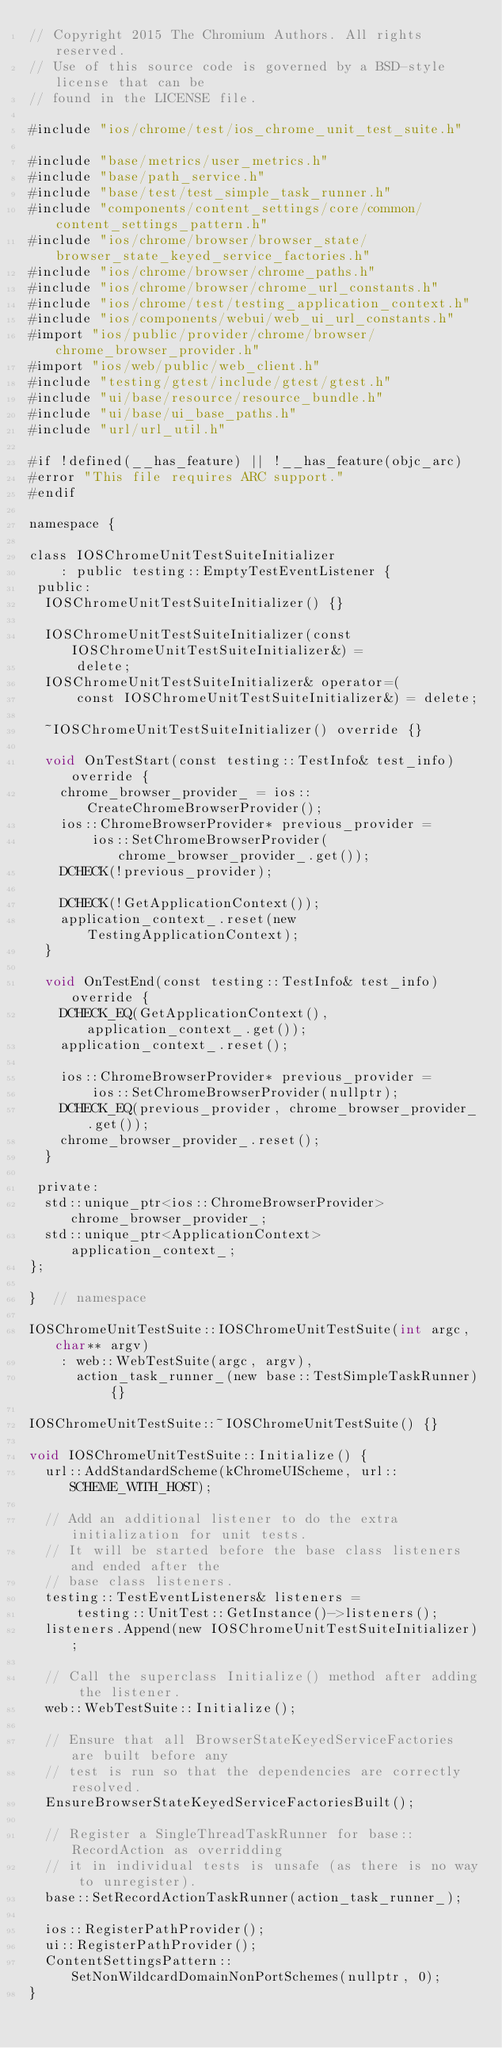<code> <loc_0><loc_0><loc_500><loc_500><_ObjectiveC_>// Copyright 2015 The Chromium Authors. All rights reserved.
// Use of this source code is governed by a BSD-style license that can be
// found in the LICENSE file.

#include "ios/chrome/test/ios_chrome_unit_test_suite.h"

#include "base/metrics/user_metrics.h"
#include "base/path_service.h"
#include "base/test/test_simple_task_runner.h"
#include "components/content_settings/core/common/content_settings_pattern.h"
#include "ios/chrome/browser/browser_state/browser_state_keyed_service_factories.h"
#include "ios/chrome/browser/chrome_paths.h"
#include "ios/chrome/browser/chrome_url_constants.h"
#include "ios/chrome/test/testing_application_context.h"
#include "ios/components/webui/web_ui_url_constants.h"
#import "ios/public/provider/chrome/browser/chrome_browser_provider.h"
#import "ios/web/public/web_client.h"
#include "testing/gtest/include/gtest/gtest.h"
#include "ui/base/resource/resource_bundle.h"
#include "ui/base/ui_base_paths.h"
#include "url/url_util.h"

#if !defined(__has_feature) || !__has_feature(objc_arc)
#error "This file requires ARC support."
#endif

namespace {

class IOSChromeUnitTestSuiteInitializer
    : public testing::EmptyTestEventListener {
 public:
  IOSChromeUnitTestSuiteInitializer() {}

  IOSChromeUnitTestSuiteInitializer(const IOSChromeUnitTestSuiteInitializer&) =
      delete;
  IOSChromeUnitTestSuiteInitializer& operator=(
      const IOSChromeUnitTestSuiteInitializer&) = delete;

  ~IOSChromeUnitTestSuiteInitializer() override {}

  void OnTestStart(const testing::TestInfo& test_info) override {
    chrome_browser_provider_ = ios::CreateChromeBrowserProvider();
    ios::ChromeBrowserProvider* previous_provider =
        ios::SetChromeBrowserProvider(chrome_browser_provider_.get());
    DCHECK(!previous_provider);

    DCHECK(!GetApplicationContext());
    application_context_.reset(new TestingApplicationContext);
  }

  void OnTestEnd(const testing::TestInfo& test_info) override {
    DCHECK_EQ(GetApplicationContext(), application_context_.get());
    application_context_.reset();

    ios::ChromeBrowserProvider* previous_provider =
        ios::SetChromeBrowserProvider(nullptr);
    DCHECK_EQ(previous_provider, chrome_browser_provider_.get());
    chrome_browser_provider_.reset();
  }

 private:
  std::unique_ptr<ios::ChromeBrowserProvider> chrome_browser_provider_;
  std::unique_ptr<ApplicationContext> application_context_;
};

}  // namespace

IOSChromeUnitTestSuite::IOSChromeUnitTestSuite(int argc, char** argv)
    : web::WebTestSuite(argc, argv),
      action_task_runner_(new base::TestSimpleTaskRunner) {}

IOSChromeUnitTestSuite::~IOSChromeUnitTestSuite() {}

void IOSChromeUnitTestSuite::Initialize() {
  url::AddStandardScheme(kChromeUIScheme, url::SCHEME_WITH_HOST);

  // Add an additional listener to do the extra initialization for unit tests.
  // It will be started before the base class listeners and ended after the
  // base class listeners.
  testing::TestEventListeners& listeners =
      testing::UnitTest::GetInstance()->listeners();
  listeners.Append(new IOSChromeUnitTestSuiteInitializer);

  // Call the superclass Initialize() method after adding the listener.
  web::WebTestSuite::Initialize();

  // Ensure that all BrowserStateKeyedServiceFactories are built before any
  // test is run so that the dependencies are correctly resolved.
  EnsureBrowserStateKeyedServiceFactoriesBuilt();

  // Register a SingleThreadTaskRunner for base::RecordAction as overridding
  // it in individual tests is unsafe (as there is no way to unregister).
  base::SetRecordActionTaskRunner(action_task_runner_);

  ios::RegisterPathProvider();
  ui::RegisterPathProvider();
  ContentSettingsPattern::SetNonWildcardDomainNonPortSchemes(nullptr, 0);
}
</code> 